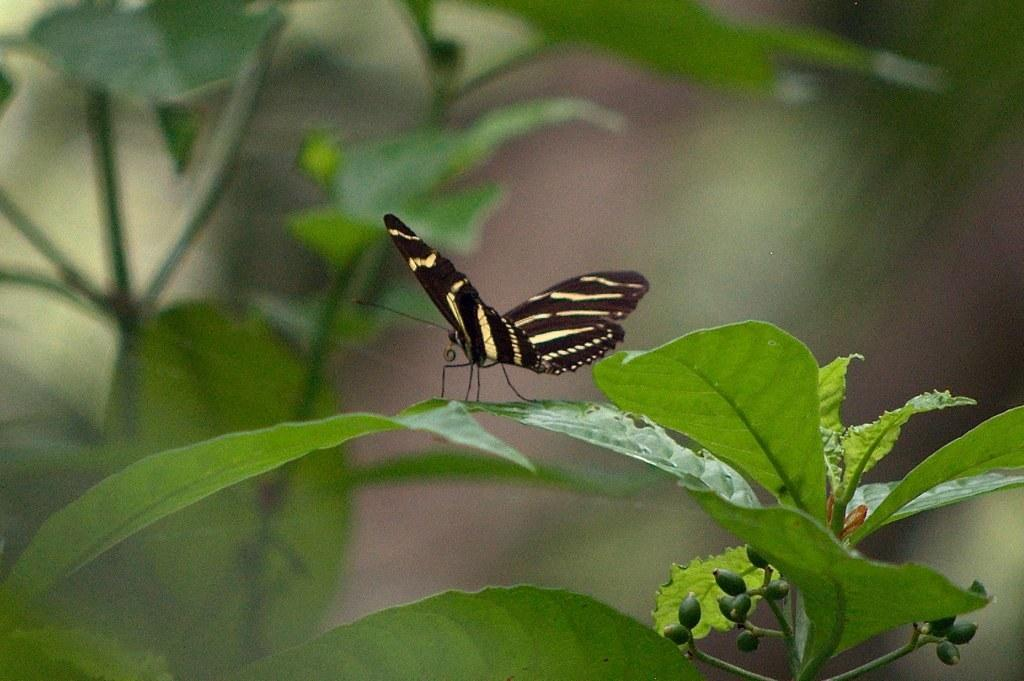What is the main subject of the picture? The main subject of the picture is a butterfly. Can you describe the colors of the butterfly? The butterfly has black and yellow colors. Where is the butterfly located in the image? The butterfly is sitting on a green leaf. How would you describe the background of the image? The background of the image is blurred. What type of degree is the butterfly pursuing in the image? There is no indication in the image that the butterfly is pursuing a degree. Can you see any harbors or boats in the image? There are no harbors or boats present in the image; it features a butterfly sitting on a green leaf. 